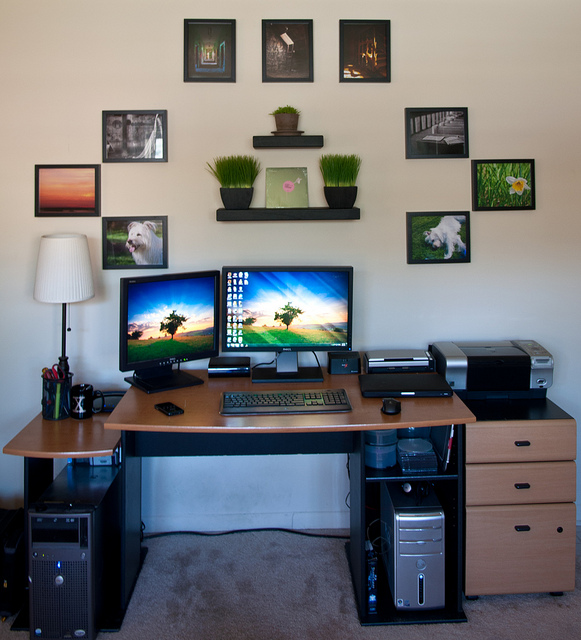<image>What type of video game system is on the desk? There is no video game system on the desk. However, it could be a 'wii', 'xbox', or 'pc'. What type of video game system is on the desk? I am not sure what type of video game system is on the desk. It can be seen 'wii', 'computer', 'xbox', 'pc' or nothing. 